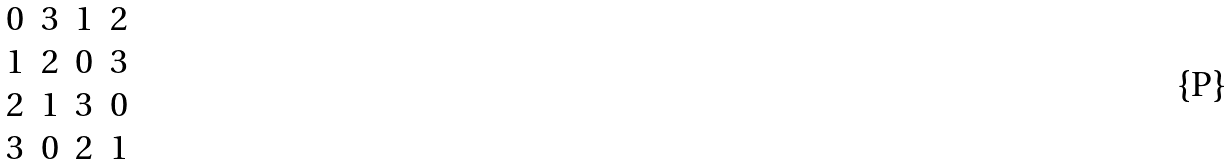<formula> <loc_0><loc_0><loc_500><loc_500>\begin{array} { c c c c } 0 & 3 & 1 & 2 \\ 1 & 2 & 0 & 3 \\ 2 & 1 & 3 & 0 \\ 3 & 0 & 2 & 1 \end{array}</formula> 